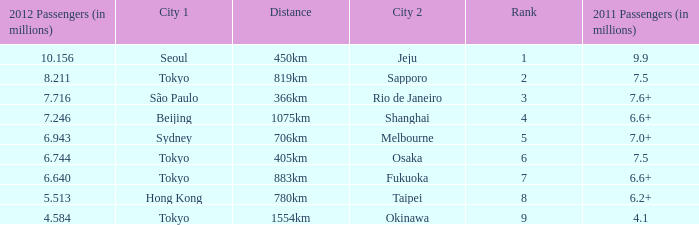How many passengers (in millions) in 2011 flew through along the route that had 6.640 million passengers in 2012? 6.6+. Could you help me parse every detail presented in this table? {'header': ['2012 Passengers (in millions)', 'City 1', 'Distance', 'City 2', 'Rank', '2011 Passengers (in millions)'], 'rows': [['10.156', 'Seoul', '450km', 'Jeju', '1', '9.9'], ['8.211', 'Tokyo', '819km', 'Sapporo', '2', '7.5'], ['7.716', 'São Paulo', '366km', 'Rio de Janeiro', '3', '7.6+'], ['7.246', 'Beijing', '1075km', 'Shanghai', '4', '6.6+'], ['6.943', 'Sydney', '706km', 'Melbourne', '5', '7.0+'], ['6.744', 'Tokyo', '405km', 'Osaka', '6', '7.5'], ['6.640', 'Tokyo', '883km', 'Fukuoka', '7', '6.6+'], ['5.513', 'Hong Kong', '780km', 'Taipei', '8', '6.2+'], ['4.584', 'Tokyo', '1554km', 'Okinawa', '9', '4.1']]} 